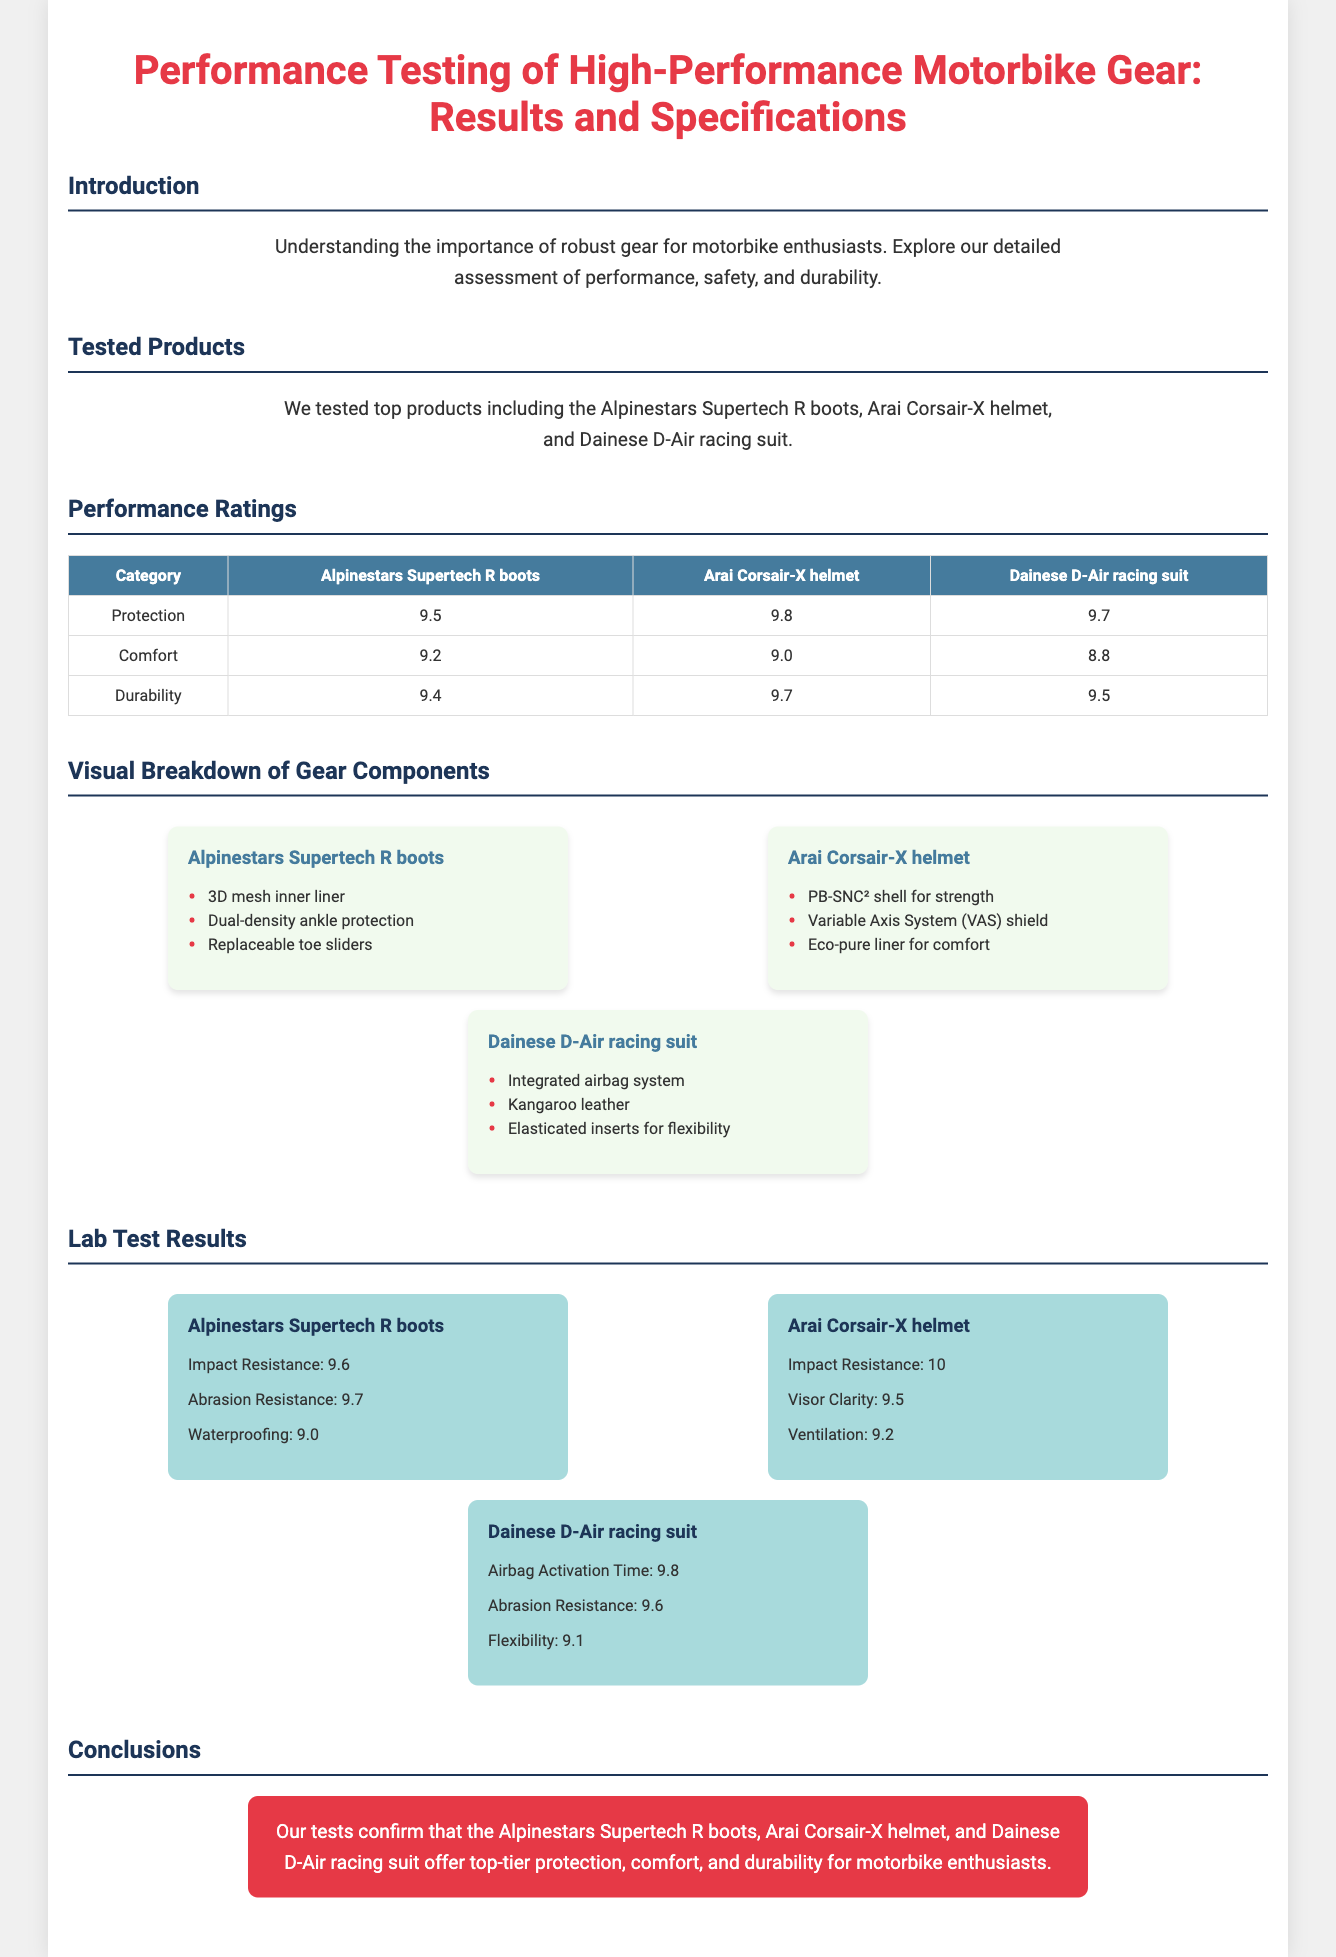What is the title of the infographic? The title is provided at the top of the document, highlighting the main focus of the content.
Answer: Performance Testing of High-Performance Motorbike Gear: Results and Specifications Which product received the highest protection rating? The protection ratings for each tested product are listed in the performance ratings table.
Answer: Arai Corsair-X helmet What is the abrasion resistance rating for the Alpinestars Supertech R boots? The specific lab test results for each product detail their abrasion resistance ratings.
Answer: 9.7 Which component is part of the Dainese D-Air racing suit? A list of components for each product can be found under their respective sections.
Answer: Integrated airbag system What is the impact resistance rating of the Arai Corsair-X helmet? The lab test results show various performance metrics, including impact resistance.
Answer: 10 Which product has the lowest comfort rating? The comfort ratings for the products are compared in the performance ratings table.
Answer: Dainese D-Air racing suit What color is used for the conclusion background? The background color of the conclusion section can be identified visually in the document.
Answer: Red How many tested products are mentioned in the introduction? The introduction specifies the number of products tested in the section.
Answer: Three 